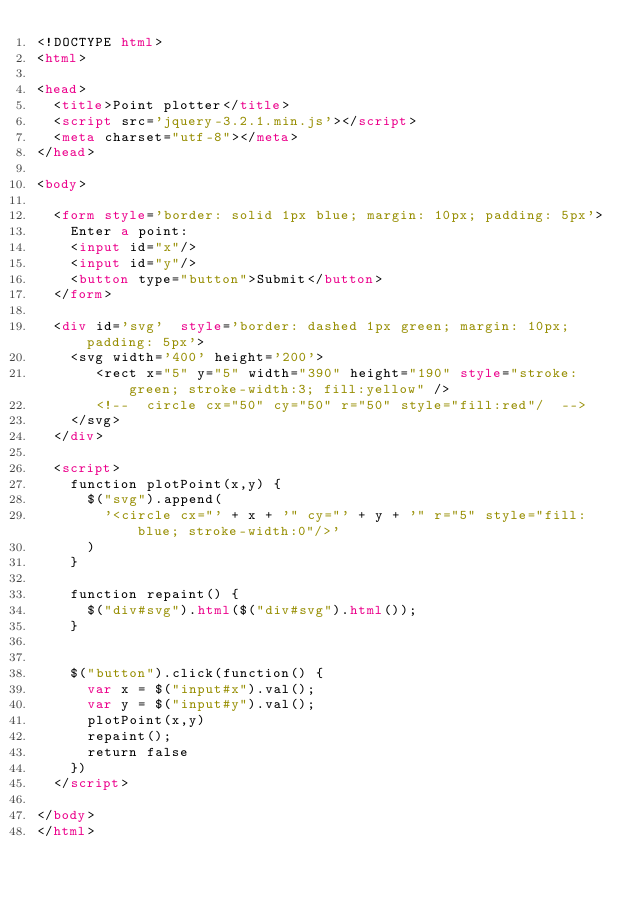<code> <loc_0><loc_0><loc_500><loc_500><_HTML_><!DOCTYPE html>
<html>

<head>
	<title>Point plotter</title>
	<script src='jquery-3.2.1.min.js'></script>
	<meta charset="utf-8"></meta>
</head>

<body>

	<form style='border: solid 1px blue; margin: 10px; padding: 5px'>
		Enter a point:
		<input id="x"/>
		<input id="y"/>
		<button type="button">Submit</button>
	</form>
	
	<div id='svg'  style='border: dashed 1px green; margin: 10px; padding: 5px'>
		<svg width='400' height='200'>
		   <rect x="5" y="5" width="390" height="190" style="stroke:green; stroke-width:3; fill:yellow" />
		   <!--  circle cx="50" cy="50" r="50" style="fill:red"/  -->
		</svg>
	</div>

	<script>
		function plotPoint(x,y) {
			$("svg").append(
				'<circle cx="' + x + '" cy="' + y + '" r="5" style="fill:blue; stroke-width:0"/>'
			)
		}
		
		function repaint() {
			$("div#svg").html($("div#svg").html());
		}
		

		$("button").click(function() {
			var x = $("input#x").val();
			var y = $("input#y").val();
			plotPoint(x,y)
			repaint();
			return false
		})
	</script>

</body>
</html>
</code> 